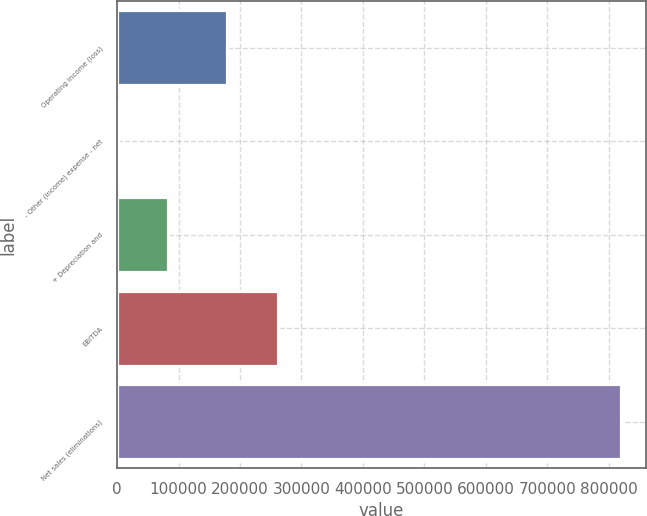Convert chart. <chart><loc_0><loc_0><loc_500><loc_500><bar_chart><fcel>Operating income (loss)<fcel>- Other (income) expense - net<fcel>+ Depreciation and<fcel>EBITDA<fcel>Net sales (eliminations)<nl><fcel>179567<fcel>795<fcel>82728.6<fcel>261501<fcel>820131<nl></chart> 